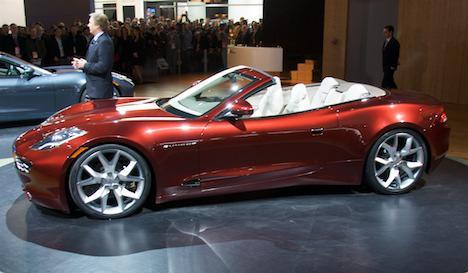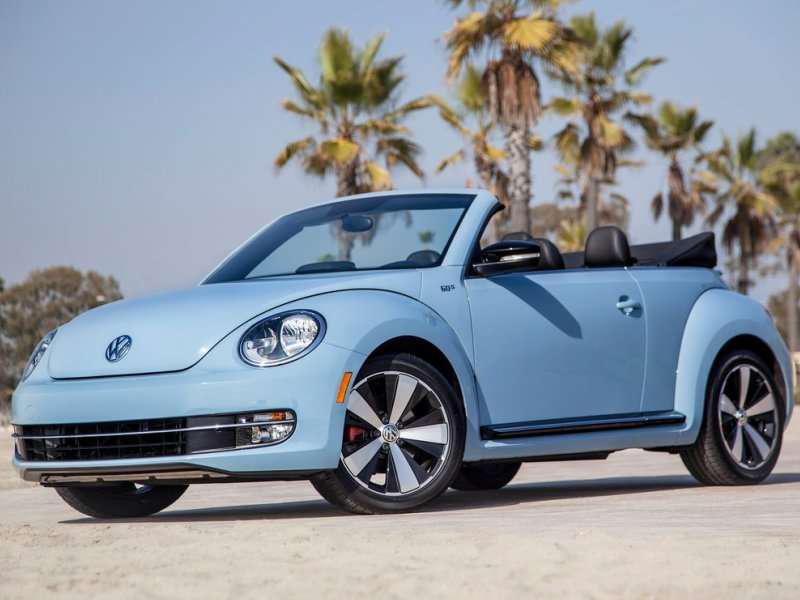The first image is the image on the left, the second image is the image on the right. Considering the images on both sides, is "there is a parked convertible on the road in fron't of a mountain background" valid? Answer yes or no. No. The first image is the image on the left, the second image is the image on the right. For the images shown, is this caption "The car in the image on the left is parked in front of a building." true? Answer yes or no. Yes. 